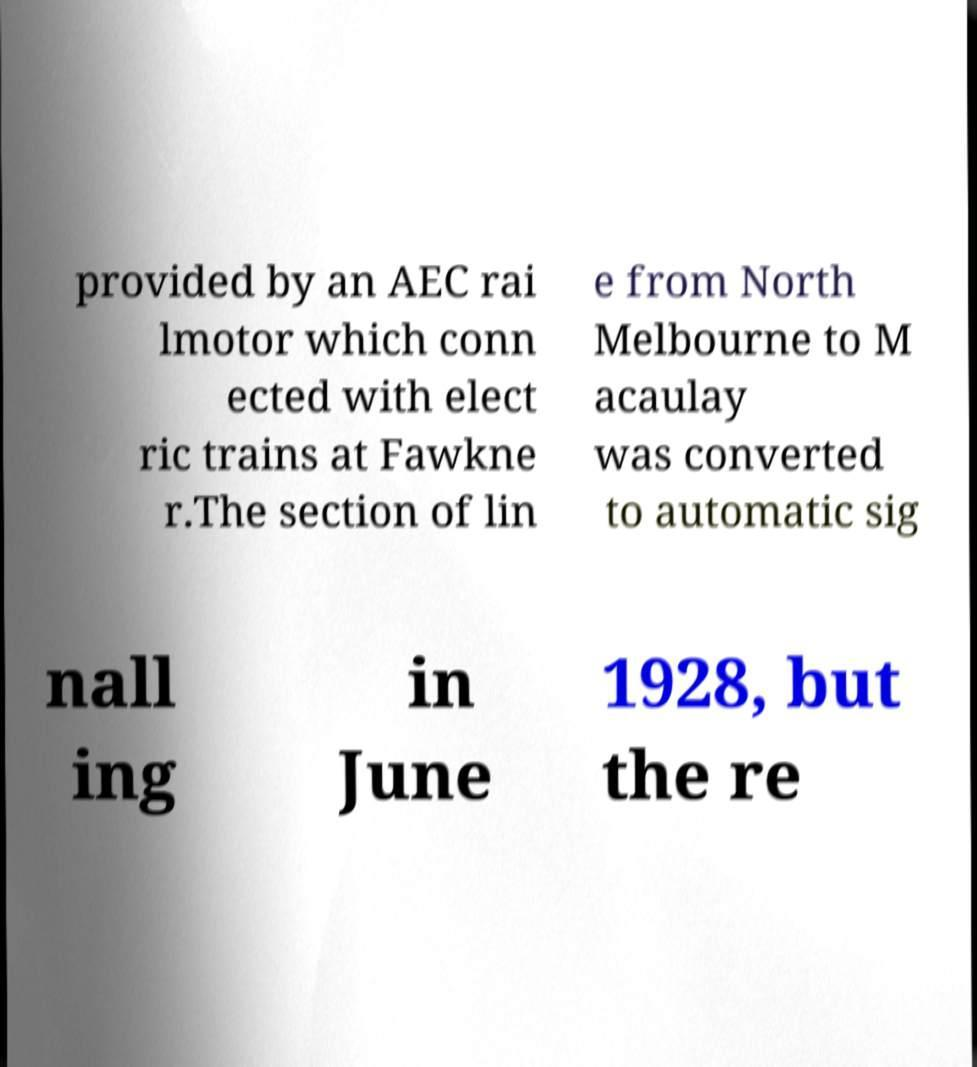Could you extract and type out the text from this image? provided by an AEC rai lmotor which conn ected with elect ric trains at Fawkne r.The section of lin e from North Melbourne to M acaulay was converted to automatic sig nall ing in June 1928, but the re 